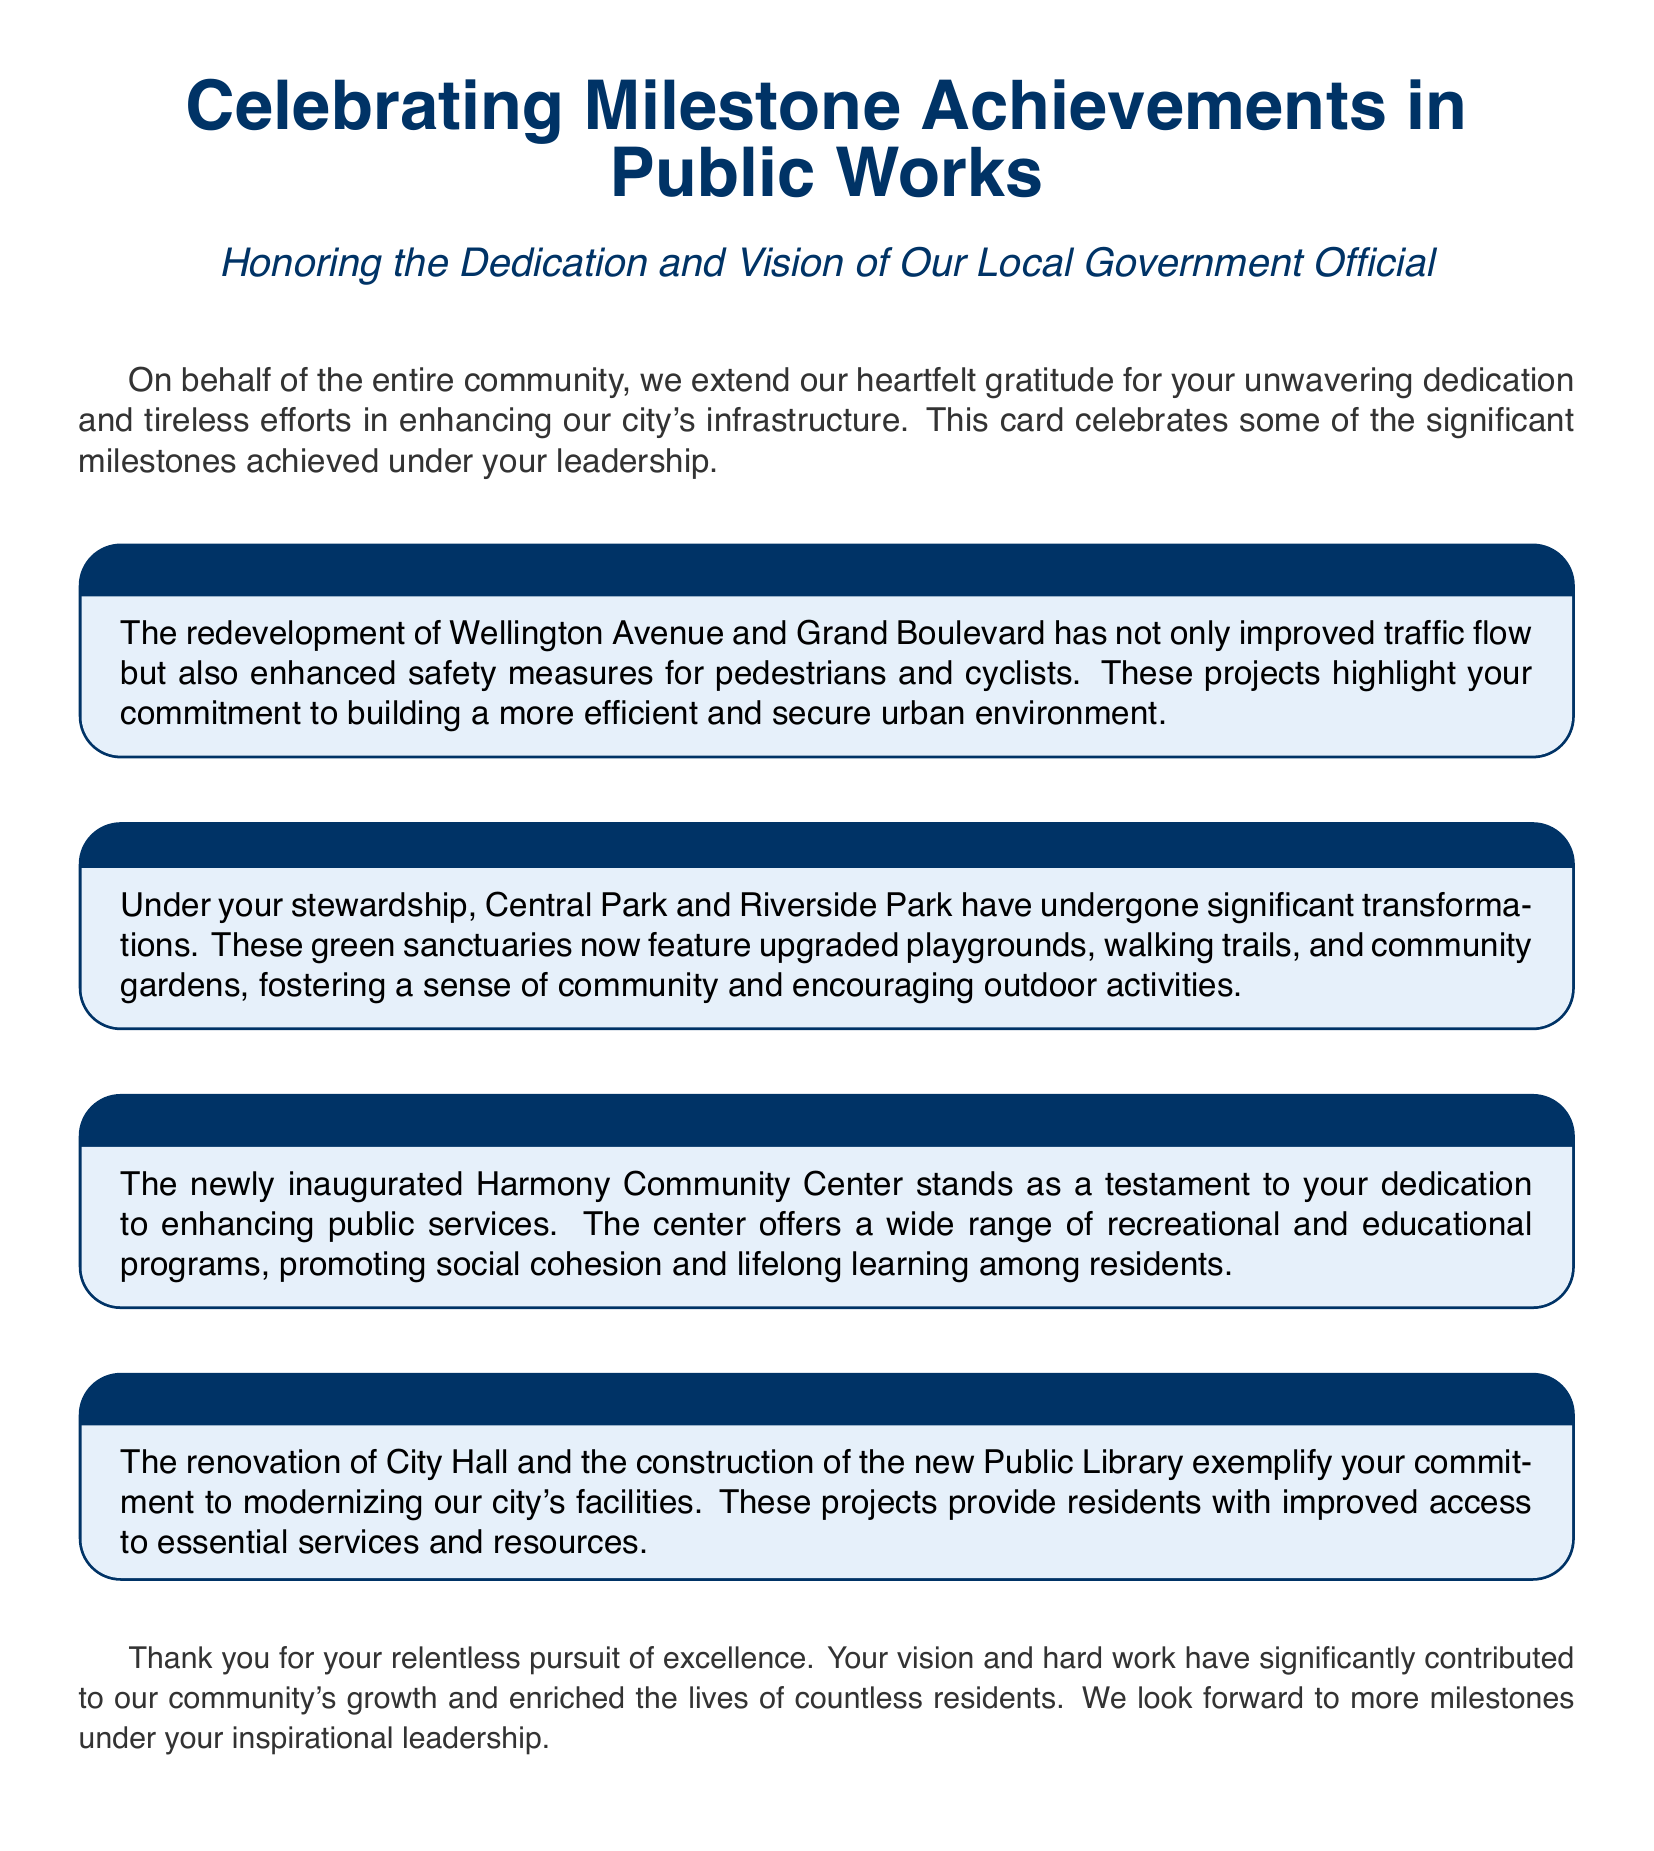what is the title of the greeting card? The title of the greeting card is the main focus that highlights the document subject, which is "Celebrating Milestone Achievements in Public Works".
Answer: Celebrating Milestone Achievements in Public Works who is honored in the card? The card explicitly mentions that it honors "Our Local Government Official," indicating that it is dedicated to the official’s efforts.
Answer: Our Local Government Official how many public parks are mentioned? The document details two revitalized parks, providing specific examples of projects that took place under the official's stewardship.
Answer: Two what is one feature of the Harmony Community Center? The document states that the center offers "a wide range of recreational and educational programs" as a significant feature of the newly inaugurated center.
Answer: Recreational and educational programs which roads were modernized? The card mentions two specific roads that have been redeveloped, which improves the overall infrastructure in the city.
Answer: Wellington Avenue and Grand Boulevard what type of document is this? The structure and content of the document are tailored specifically for a purpose, which indicates it is a celebratory card recognizing achievements.
Answer: Greeting card what color is used for the title text? The document specifies the RGB color value for the title text, ensuring consistent visual design throughout the celebration.
Answer: RGB(0,51,102) what did the renovations of City Hall exemplify? The document states that the renovations exemplify the official’s commitment to modernizing facilities and improving access to services.
Answer: Modernizing our city's facilities 